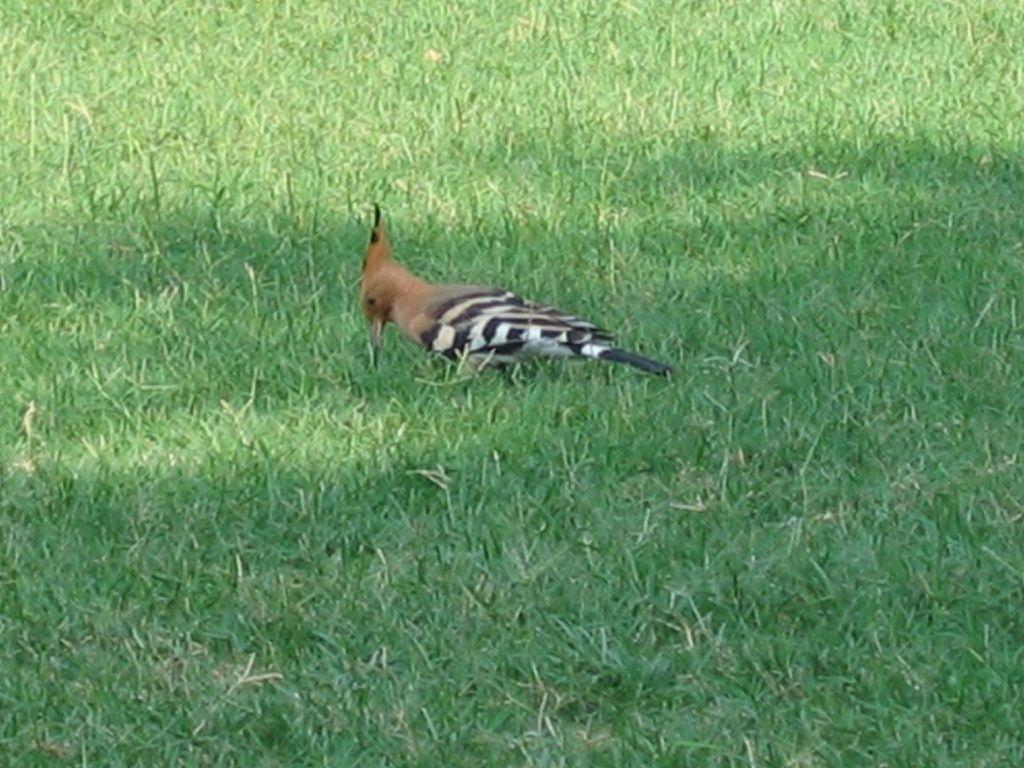What type of vegetation is present in the image? There is grass in the image. What type of animal can be seen in the image? There is a bird in the image. Can you describe the bird's appearance? The bird has a brown, black, and white coloration. What else can be observed in the image? There is a shadow visible in the image. What is the price of the square in the image? There is no square present in the image, and therefore no price can be determined. Can you describe the snake in the image? There is no snake present in the image. 